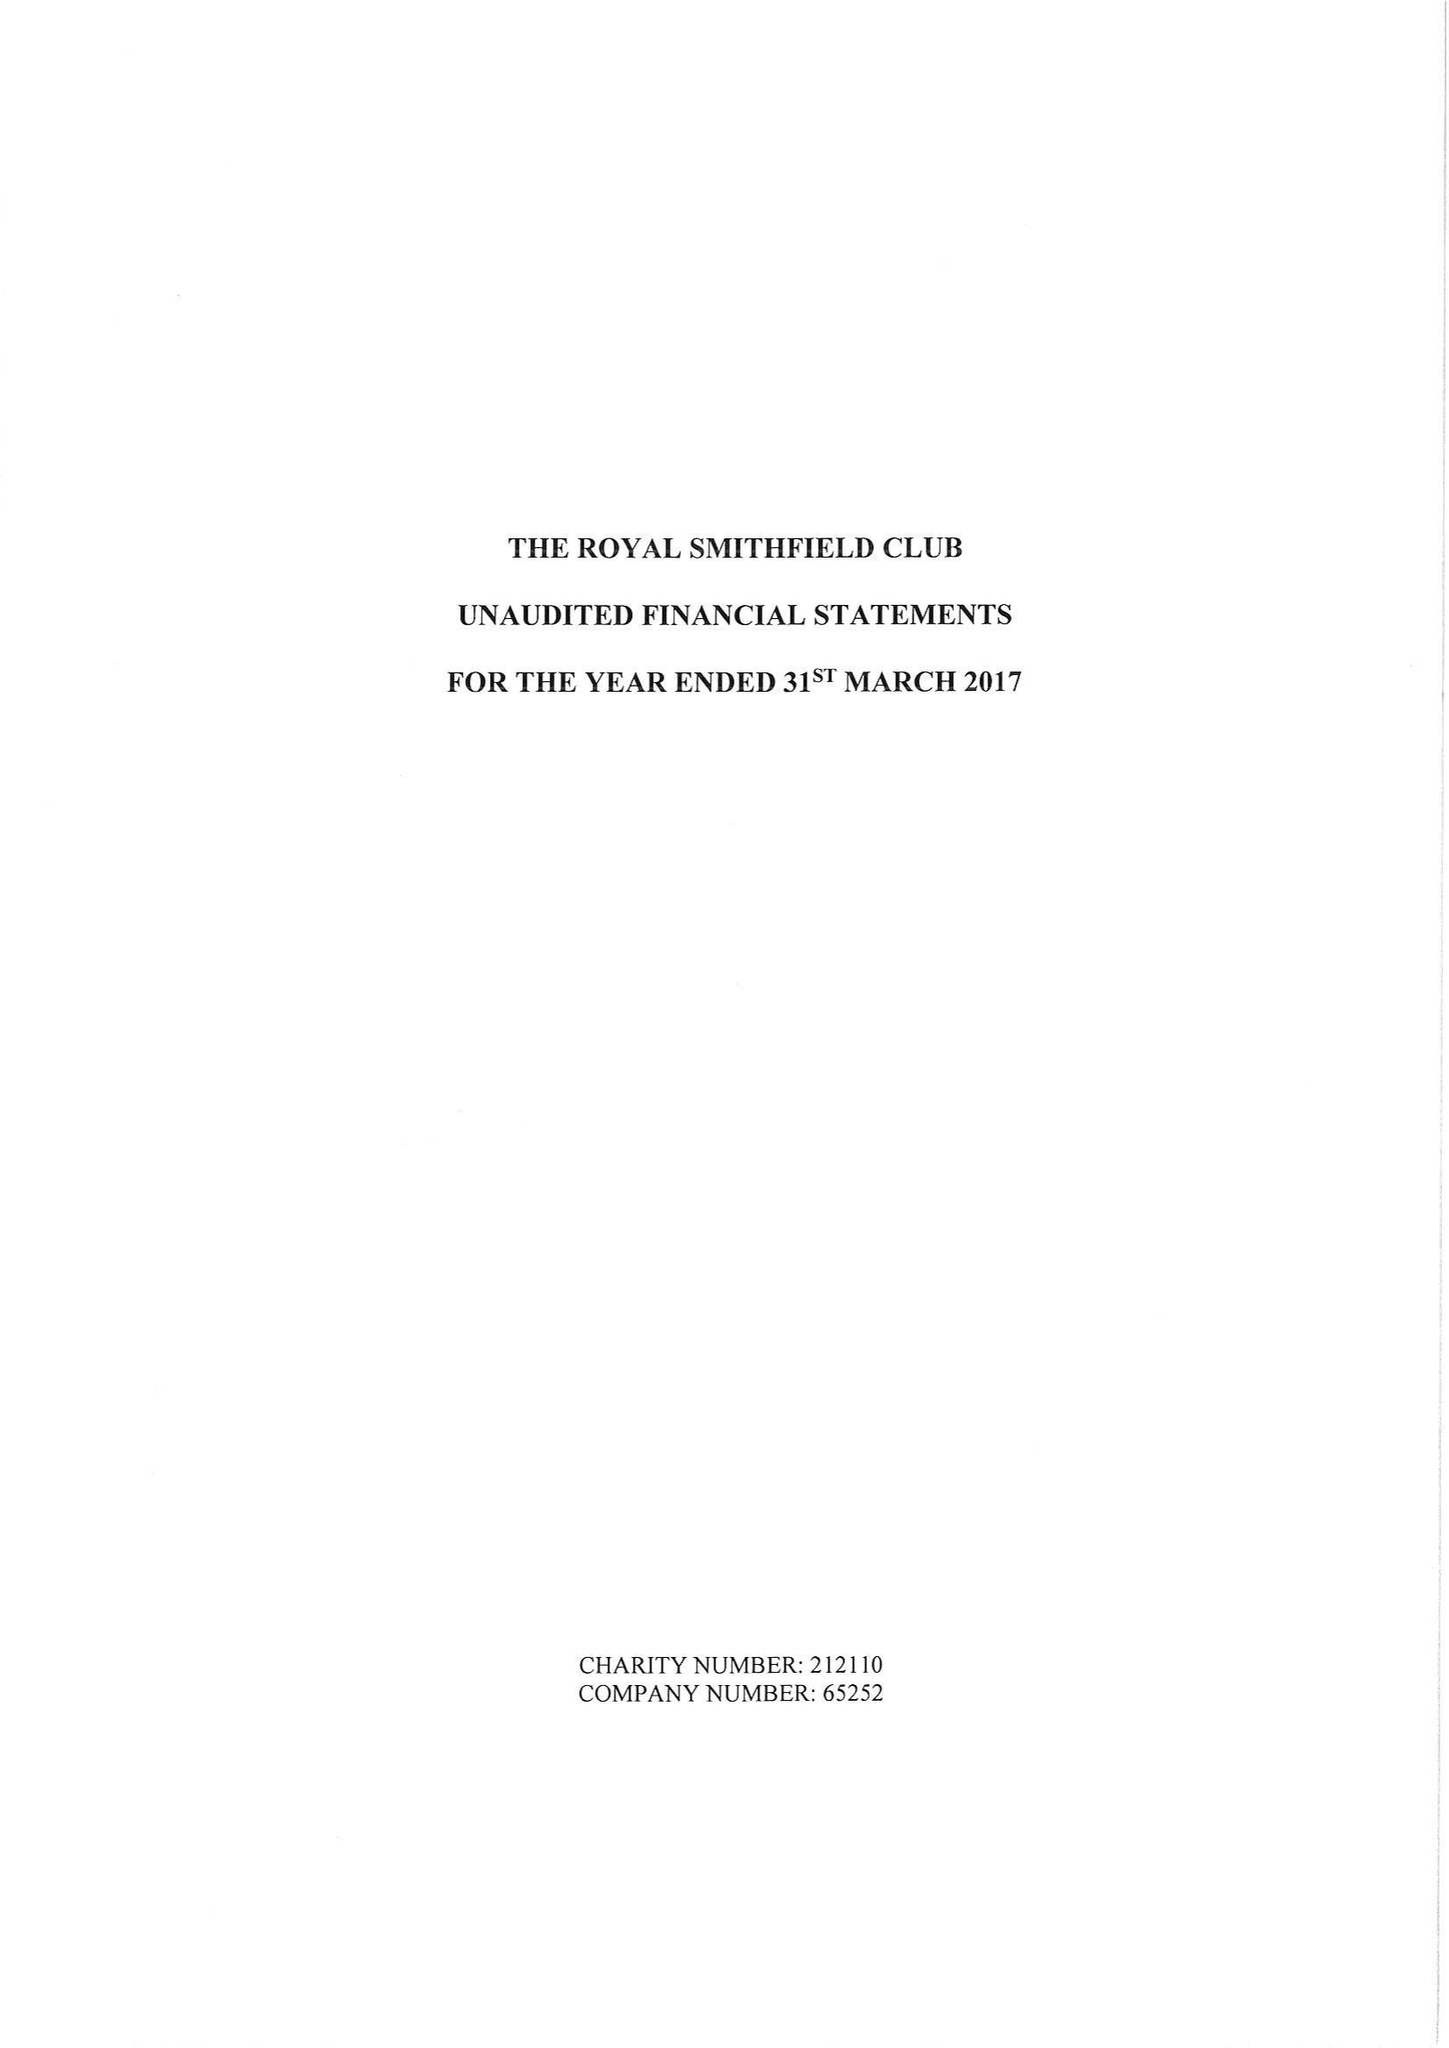What is the value for the address__street_line?
Answer the question using a single word or phrase. None 